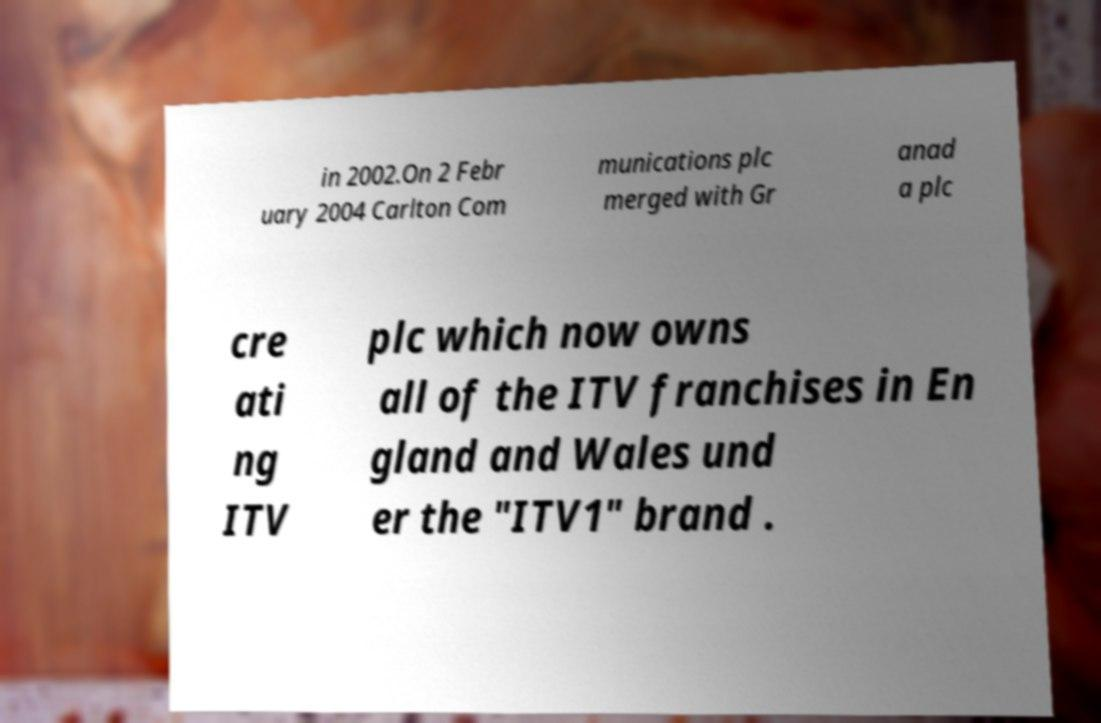There's text embedded in this image that I need extracted. Can you transcribe it verbatim? in 2002.On 2 Febr uary 2004 Carlton Com munications plc merged with Gr anad a plc cre ati ng ITV plc which now owns all of the ITV franchises in En gland and Wales und er the "ITV1" brand . 